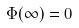<formula> <loc_0><loc_0><loc_500><loc_500>\Phi ( \infty ) = 0</formula> 